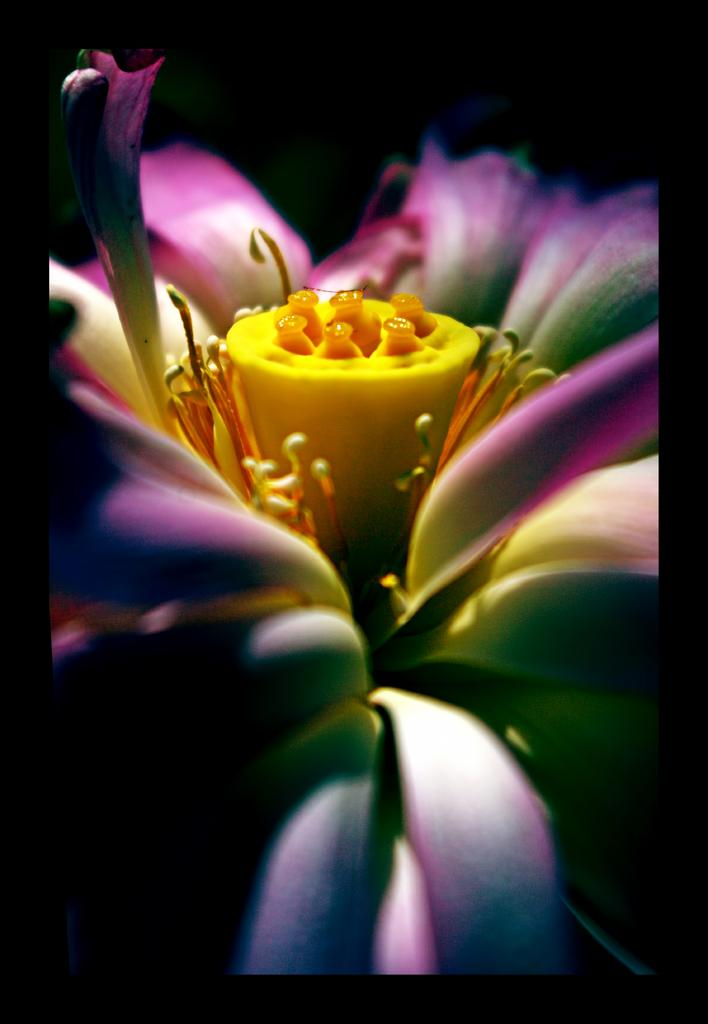What is the main subject of the image? There is a flower in the image. What color is the flower? The flower is purple in color. What type of mask is the flower wearing in the image? There is no mask present in the image, as it features a flower. What can be used to draw on the sidewalk near the flower in the image? There is no mention of chalk or drawing in the image, as it only features a flower. 